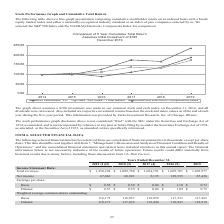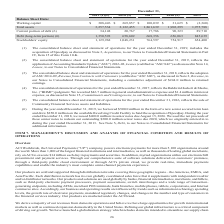According to Aci Worldwide's financial document, What does the consolidated balance sheet and statement of operations for the year ended December 31, 2019, include? the acquisition of Speedpay. The document states: "ns for the year ended December 31, 2019, includes the acquisition of Speedpay as discussed in Note 3, Acquisition , to our Notes to Consolidated Finan..." Also, What was the total revenues in 2019? According to the financial document, $ 1,258,294 (in thousands). The relevant text states: "Total revenues $ 1,258,294 $ 1,009,780 $ 1,024,191 $ 1,005,701 $ 1,045,977..." Also, What was the net income in 2019? According to the financial document, 67,062 (in thousands). The relevant text states: "Net income 67,062 68,921 5,135 129,535 85,436..." Also, can you calculate: What was the percentage change in net income between 2018 and 2019? To answer this question, I need to perform calculations using the financial data. The calculation is: (67,062-68,921)/68,921, which equals -2.7 (percentage). This is based on the information: "Net income 67,062 68,921 5,135 129,535 85,436 Net income 67,062 68,921 5,135 129,535 85,436..." The key data points involved are: 67,062, 68,921. Also, can you calculate: What was the percentage change in basic earnings per share between 2017 and 2018? To answer this question, I need to perform calculations using the financial data. The calculation is: ($0.59-$0.04)/$0.04, which equals 1375 (percentage). This is based on the information: "Basic $ 0.58 $ 0.59 $ 0.04 $ 1.10 $ 0.73 Basic $ 0.58 $ 0.59 $ 0.04 $ 1.10 $ 0.73..." The key data points involved are: 0.04, 0.59. Also, can you calculate: What was the change in net income between 2015 and 2016? Based on the calculation: 129,535-85,436, the result is 44099 (in thousands). This is based on the information: "Net income 67,062 68,921 5,135 129,535 85,436 Net income 67,062 68,921 5,135 129,535 85,436..." The key data points involved are: 129,535, 85,436. 